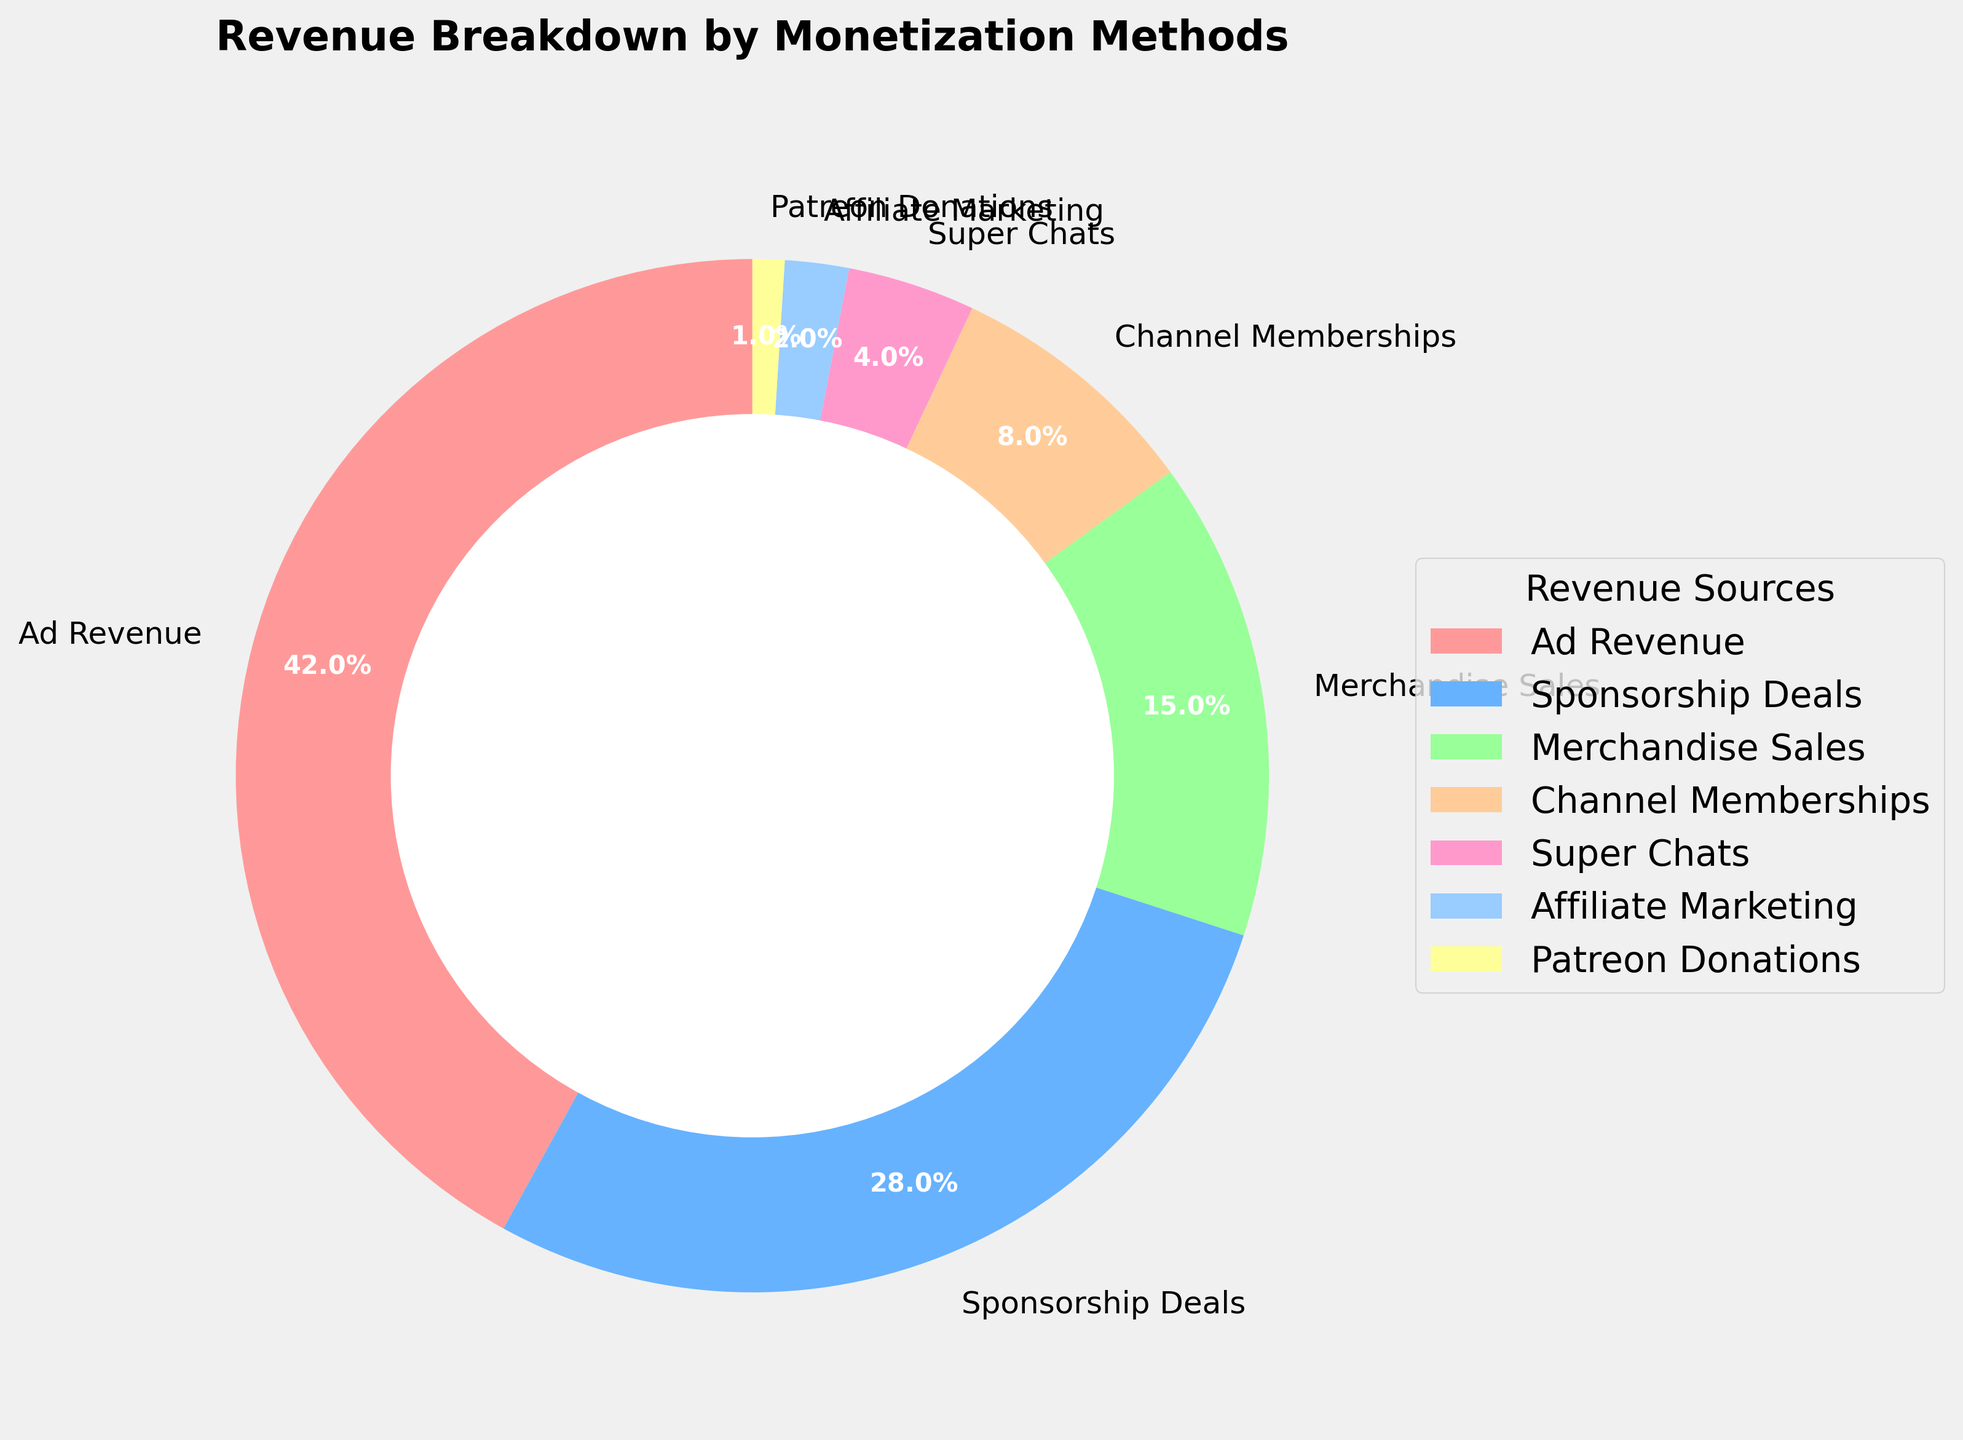What is the largest revenue source? The largest revenue source can be identified by finding the section of the pie chart with the largest slice. The slice for "Ad Revenue" is the largest.
Answer: Ad Revenue Which revenue source contributes the smallest percentage? To determine the smallest contributor, we look for the smallest slice of the pie chart. The smallest slice is for "Patreon Donations."
Answer: Patreon Donations How much more does Sponsorship Deals contribute compared to Merchandise Sales? Sponsorship Deals contribute 28%, and Merchandise Sales contribute 15%. Subtracting gives 28% - 15% = 13%.
Answer: 13% What percentage of revenue comes from Subscription-related sources (Channel Memberships and Patreon Donations)? Add the percentages for Channel Memberships (8%) and Patreon Donations (1%) together. The sum is 8% + 1% = 9%.
Answer: 9% Which two revenue sources are almost equal in their contributions? By visually comparing the sizes of the slices, Channel Memberships (8%) and Super Chats (4%) appear to have smaller differences. However, Channel Memberships and Merchandise Sales are closer with values of 8% and 15%, respectively. The more precise comparison shows Channel Memberships and Super Chats are not equal, as the difference is more significant.
Answer: Channel Memberships and Super Chats are more accurately distinguishable as not almost equal, but closer in range What is the combined contribution percentage of the three smallest revenue sources? The three smallest sources are Super Chats (4%), Affiliate Marketing (2%), and Patreon Donations (1%). Adding these gives 4% + 2% + 1% = 7%.
Answer: 7% Is the revenue from Sponsorship Deals greater than the combined revenue from Channels Memberships and Merchandise Sales? Sponsorship Deals are at 28%. Channel Memberships are at 8% and Merchandise Sales are at 15%. The combined value of Channel Memberships and Merchandise Sales is 8% + 15% = 23%. Since 28% > 23%, the revenue from Sponsorship Deals is indeed greater.
Answer: Yes Which color represents Ad Revenue? By looking at the color-coded segments, Ad Revenue is represented by the red-colored segment. This can be verified through the legend on the chart.
Answer: Red 